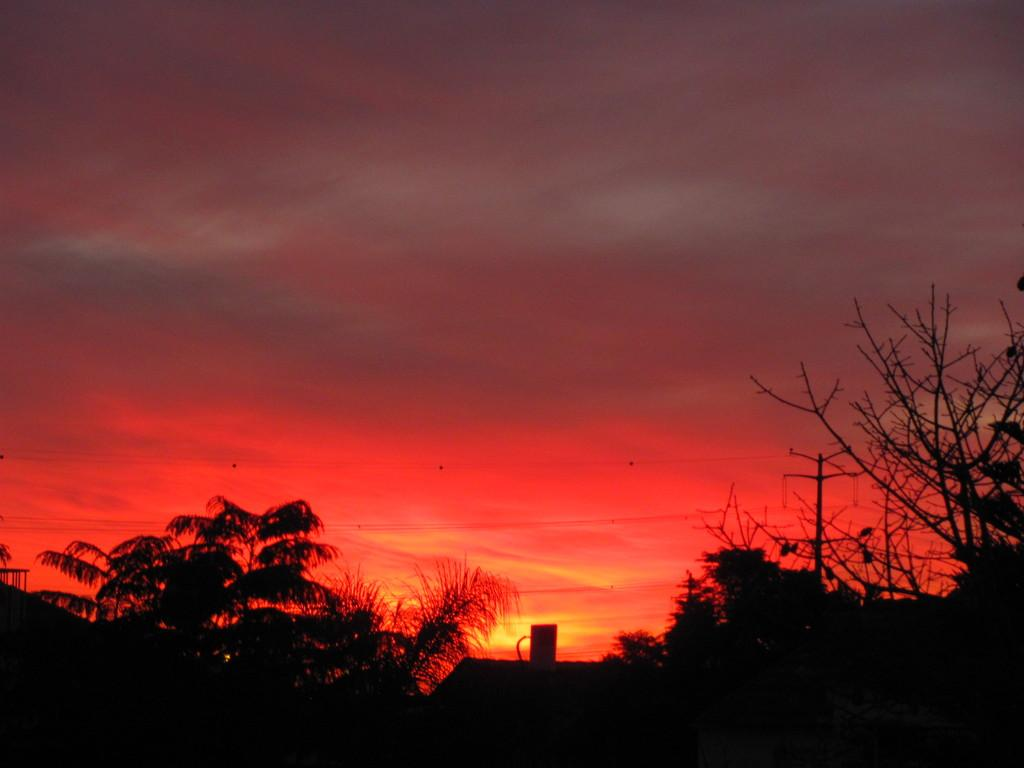What can be seen in the background of the image? The sky is visible in the background of the image. What type of vegetation is present in the image? There are trees in the image. What structure can be seen in the image? There is a transmission pole in the image. What is connected to the transmission pole? Wires are present in the image. What type of current is flowing through the wires in the image? There is no information about the type of current flowing through the wires in the image. Can you see any evidence of a crush in the image? There is no mention of a crush or any related elements in the image. 